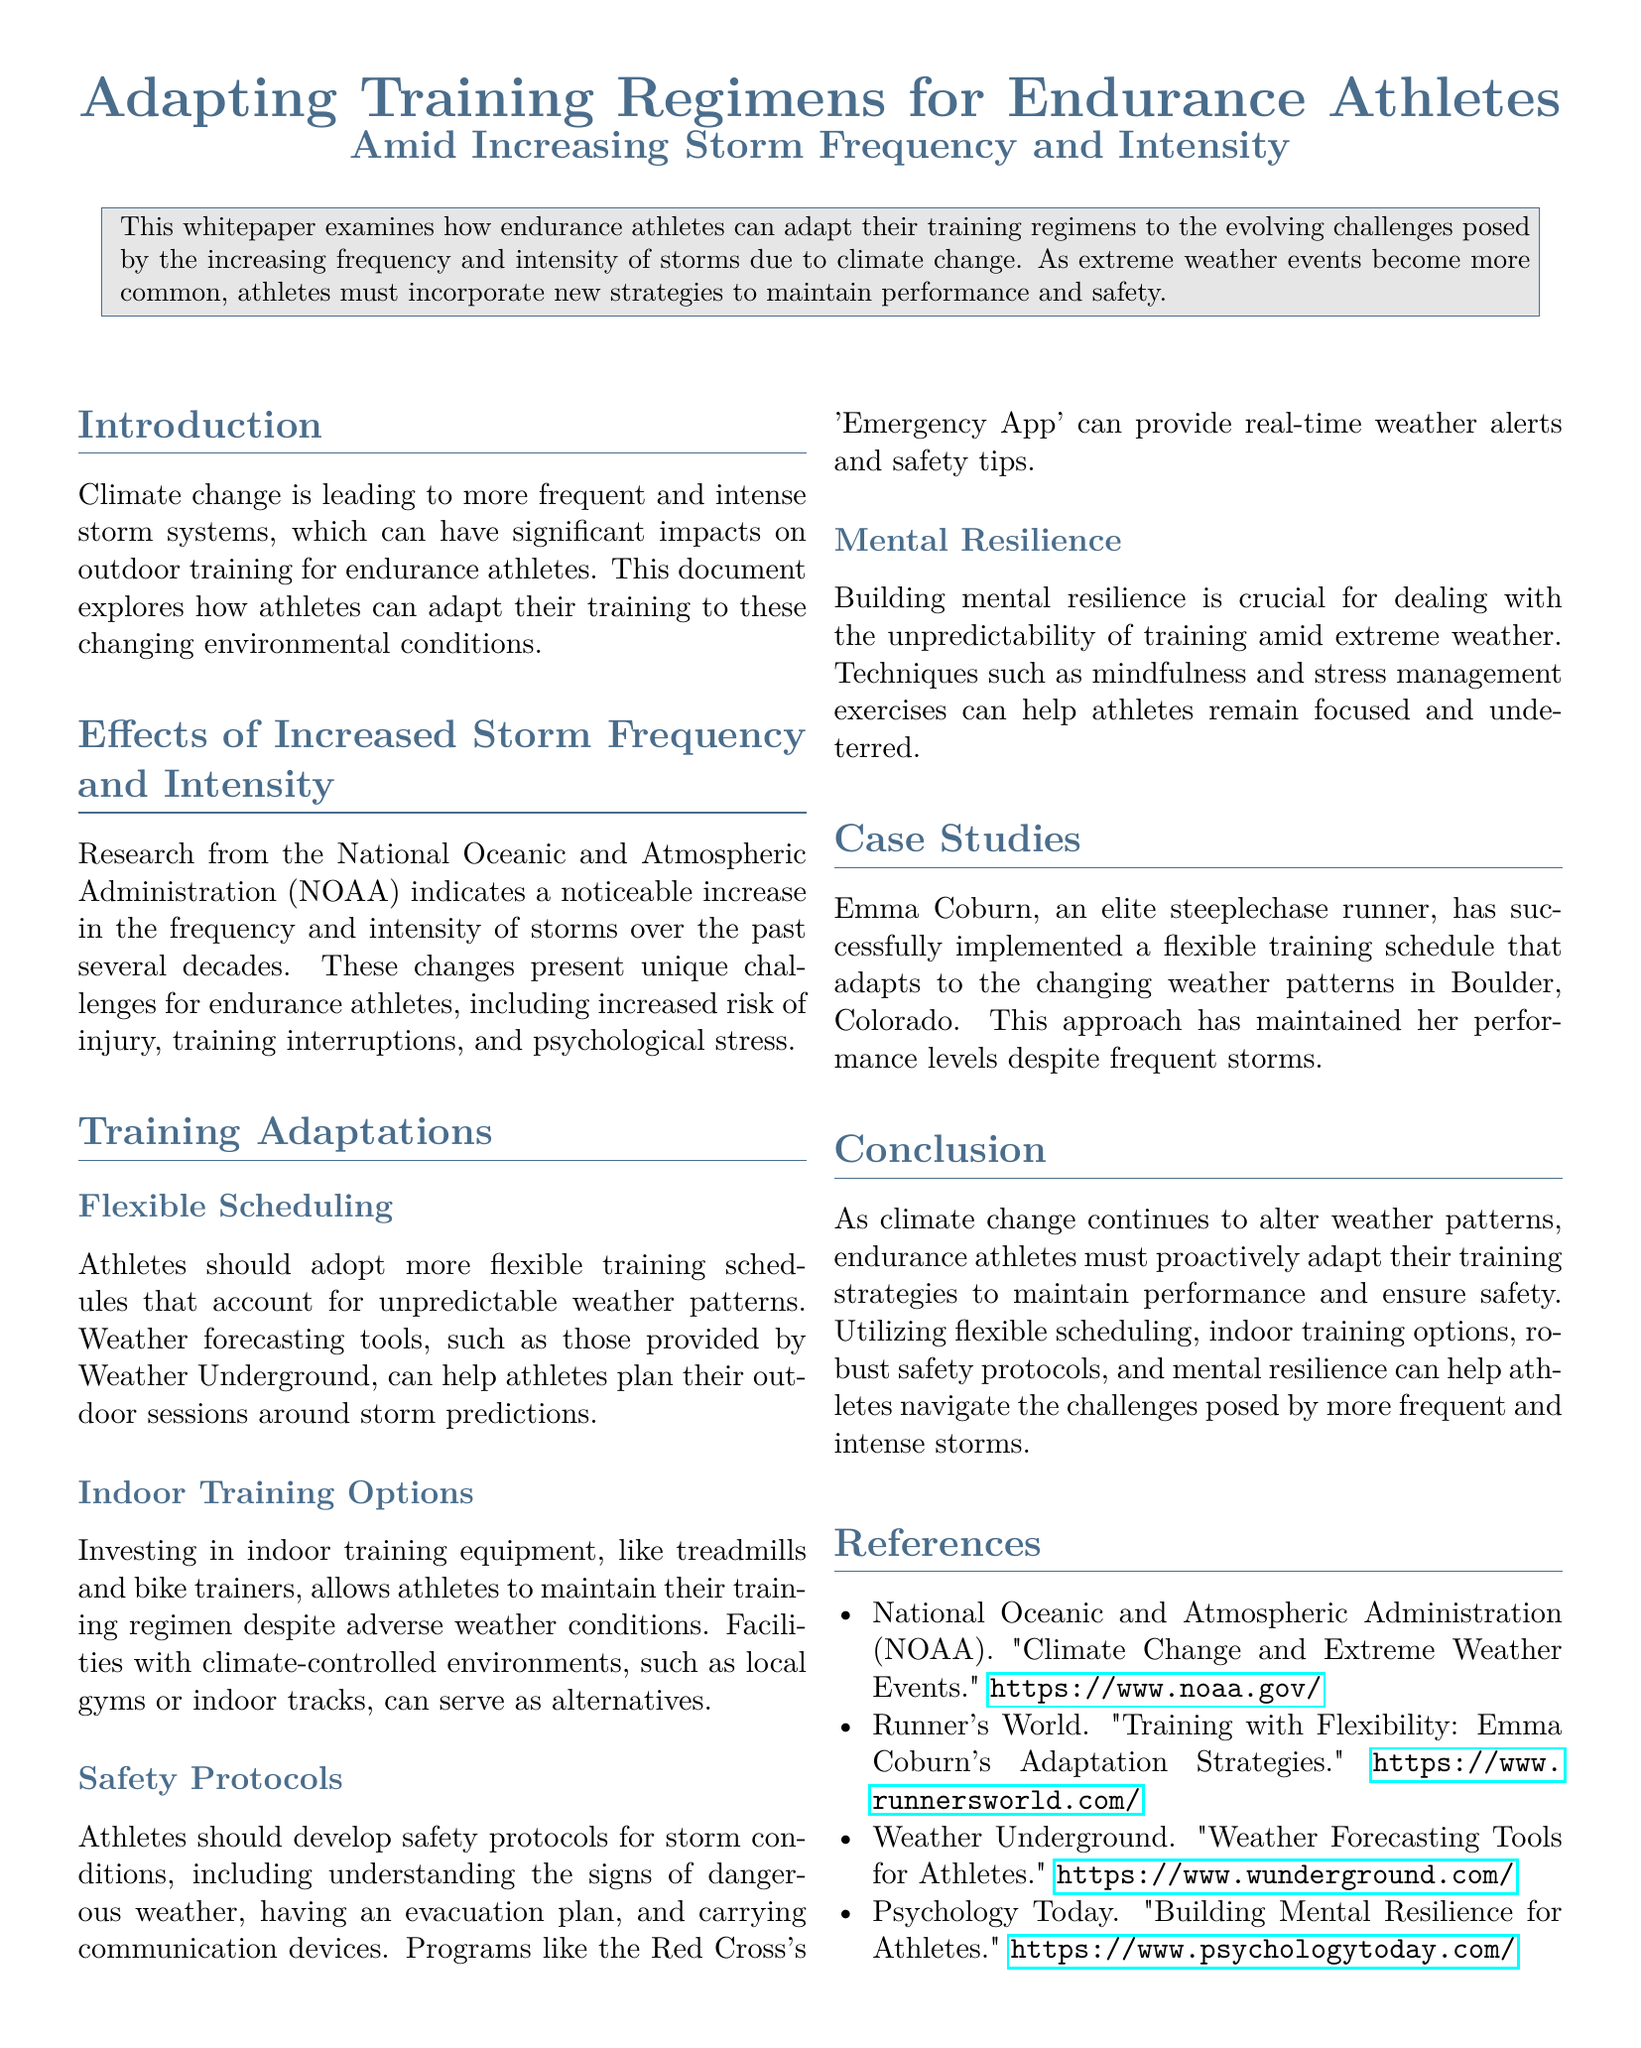What is the main focus of the whitepaper? The whitepaper examines how endurance athletes can adapt their training regimens to the evolving challenges posed by the increasing frequency and intensity of storms due to climate change.
Answer: Adapting training regimens for endurance athletes Which organization reported the increase in storm frequency and intensity? The document cites research from the National Oceanic and Atmospheric Administration (NOAA).
Answer: National Oceanic and Atmospheric Administration (NOAA) What is one recommended training adaptation for athletes? The document suggests adopting more flexible training schedules to account for unpredictable weather patterns.
Answer: Flexible Scheduling Who is a case study mentioned in the document? The case study features Emma Coburn, an elite steeplechase runner.
Answer: Emma Coburn What is a safety protocol mentioned for storm conditions? The document advises athletes to understand the signs of dangerous weather.
Answer: Understanding the signs of dangerous weather What mental technique is encouraged for athletes? The document recommends mindfulness and stress management exercises to build mental resilience.
Answer: Mindfulness What tool is suggested for weather forecasting? Weather Underground is mentioned as a resource for weather forecasting tools for athletes.
Answer: Weather Underground How does the whitepaper conclude? It emphasizes the need for endurance athletes to proactively adapt their training strategies.
Answer: Proactively adapt their training strategies 